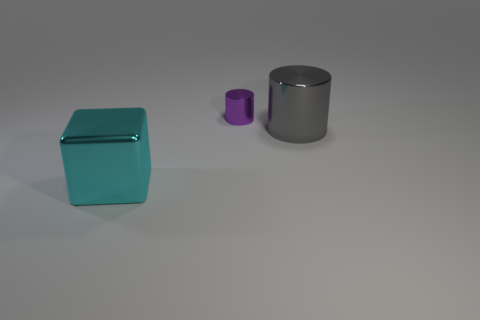Add 2 small gray shiny cubes. How many objects exist? 5 Subtract all cylinders. How many objects are left? 1 Subtract 0 blue cylinders. How many objects are left? 3 Subtract 1 cubes. How many cubes are left? 0 Subtract all blue cubes. Subtract all green balls. How many cubes are left? 1 Subtract all cyan spheres. How many purple cylinders are left? 1 Subtract all small purple metallic cylinders. Subtract all shiny blocks. How many objects are left? 1 Add 2 cyan cubes. How many cyan cubes are left? 3 Add 3 tiny purple metallic cubes. How many tiny purple metallic cubes exist? 3 